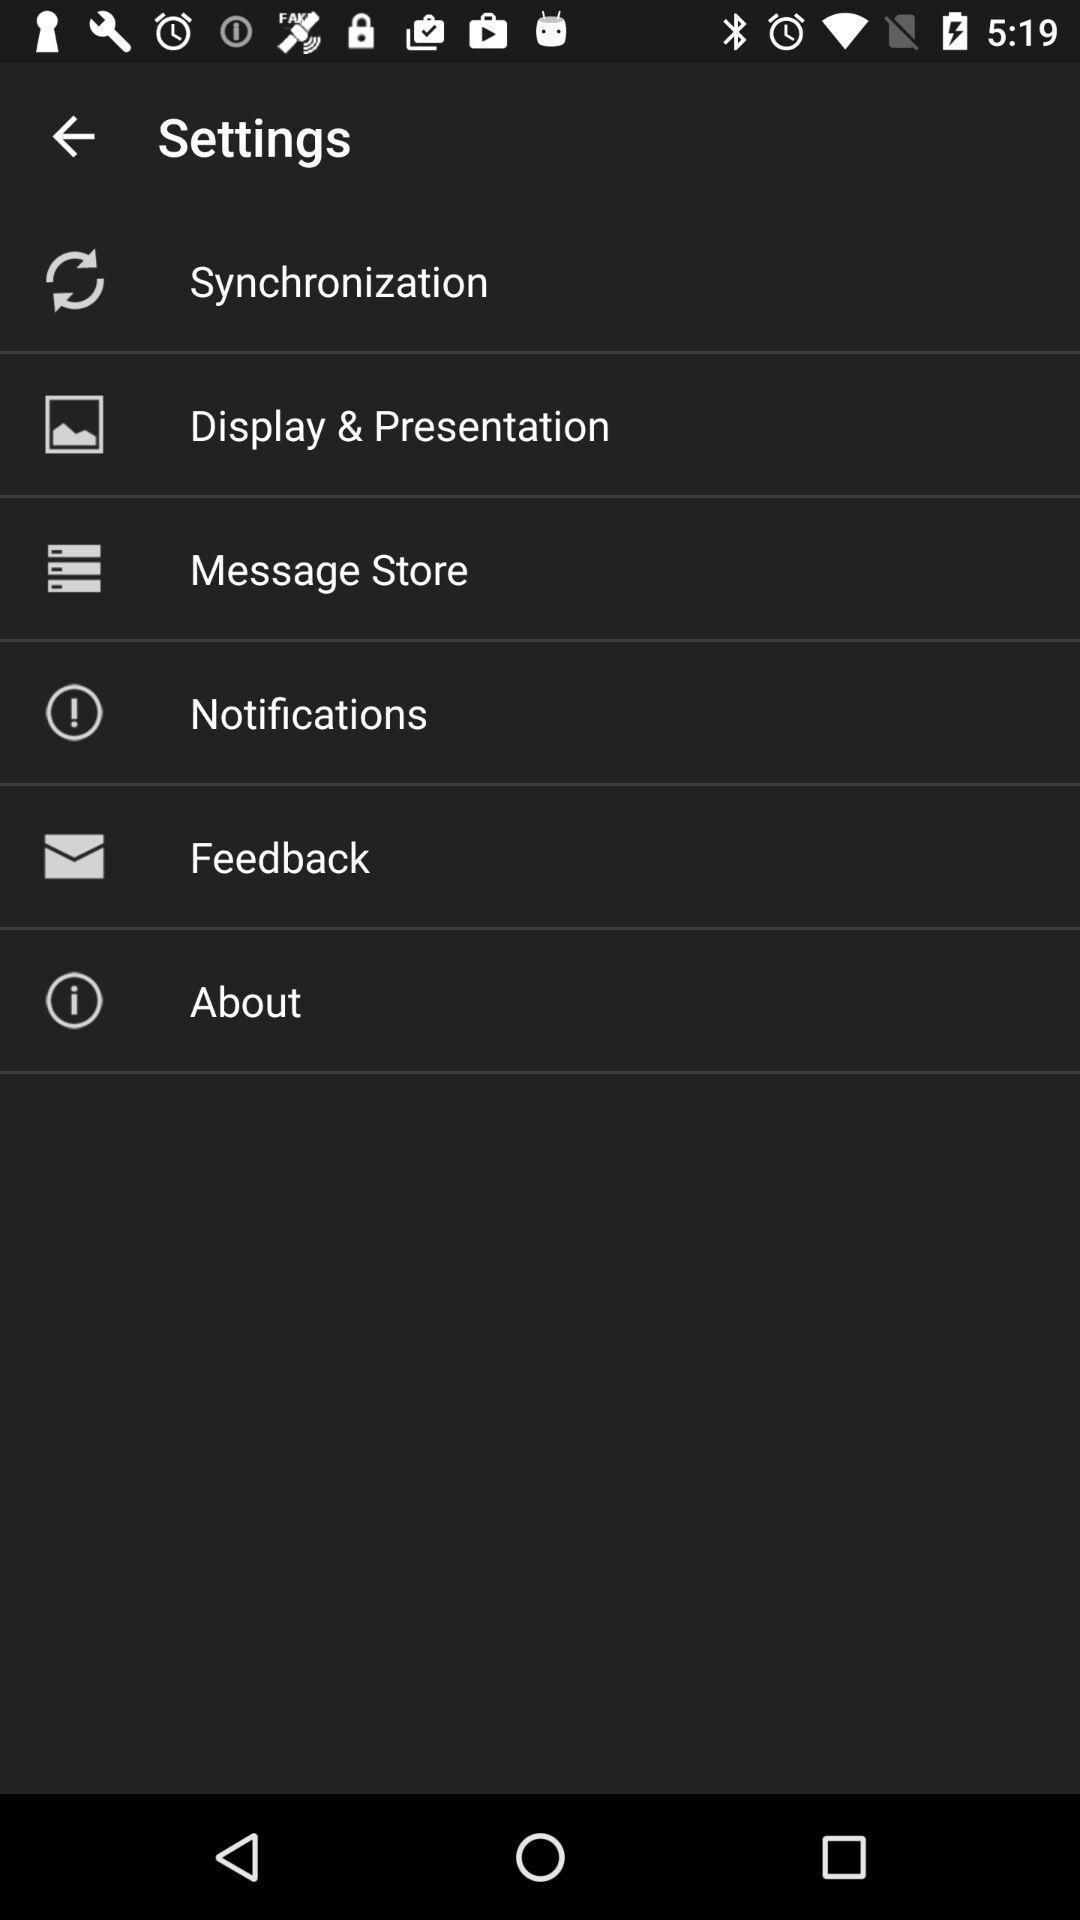Provide a detailed account of this screenshot. Settings page with list of options. 